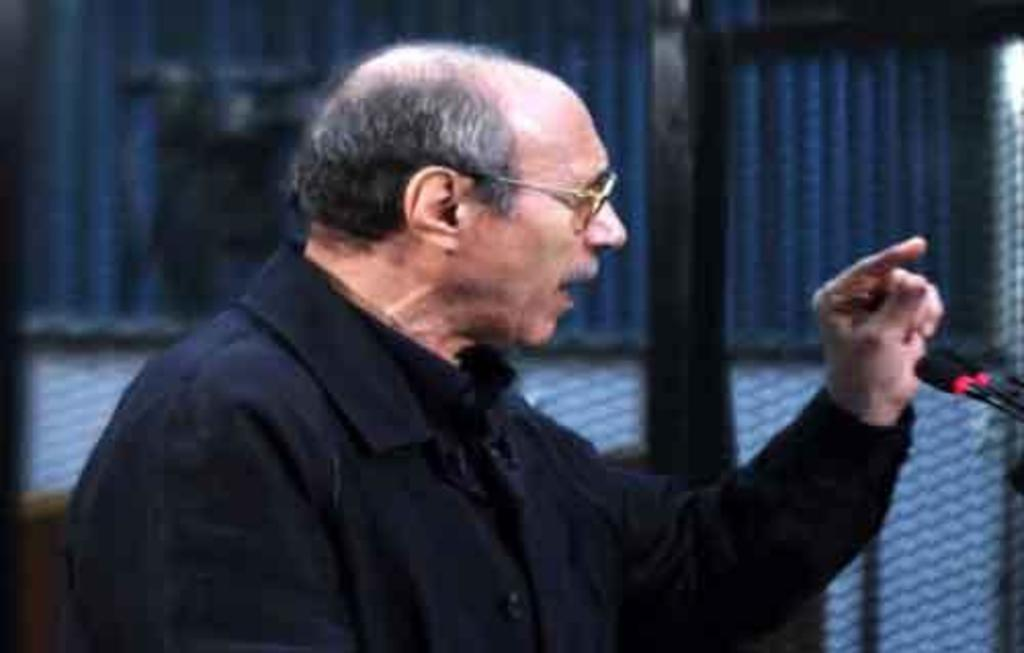Who is present in the image? There is a person in the image. What is the person wearing? The person is wearing a black dress. Are there any accessories visible on the person? Yes, the person is wearing spectacles. What is the person's posture in the image? The person is standing. What object is present near the person? There is a microphone in the image. Can you see any bones in the image? There are no bones visible in the image. What type of rhythm is the person following in the image? The image does not provide any information about the person's rhythm or musical activity. 